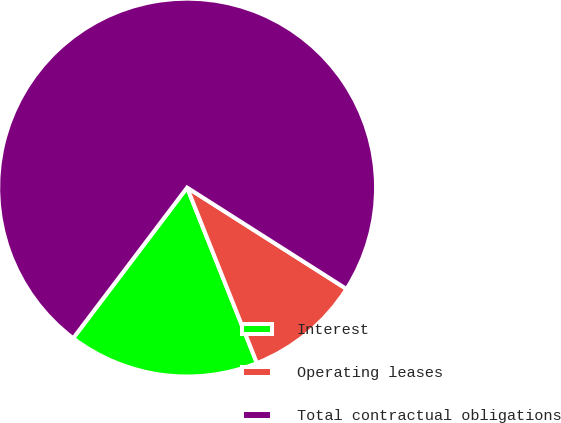<chart> <loc_0><loc_0><loc_500><loc_500><pie_chart><fcel>Interest<fcel>Operating leases<fcel>Total contractual obligations<nl><fcel>16.33%<fcel>9.96%<fcel>73.71%<nl></chart> 